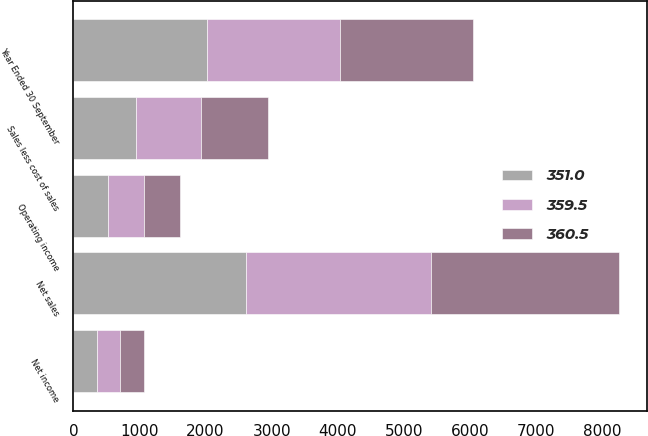Convert chart. <chart><loc_0><loc_0><loc_500><loc_500><stacked_bar_chart><ecel><fcel>Year Ended 30 September<fcel>Net sales<fcel>Sales less cost of sales<fcel>Operating income<fcel>Net income<nl><fcel>351<fcel>2015<fcel>2604.3<fcel>949.2<fcel>524<fcel>351<nl><fcel>359.5<fcel>2014<fcel>2808.7<fcel>984.7<fcel>542.9<fcel>359.5<nl><fcel>360.5<fcel>2013<fcel>2845.9<fcel>1003.3<fcel>547.3<fcel>360.5<nl></chart> 